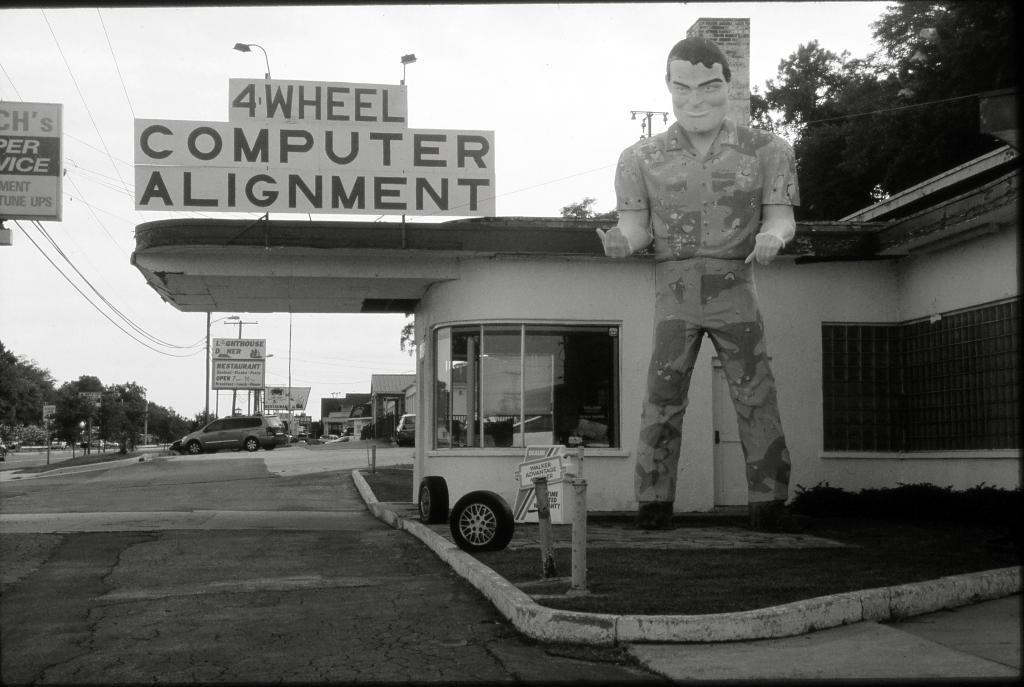In one or two sentences, can you explain what this image depicts? In this picture i can see buildings, trees and few hoardings with text and pole lights and poles and a statue of a man and couple of tires on the ground and a cloudy Sky. 